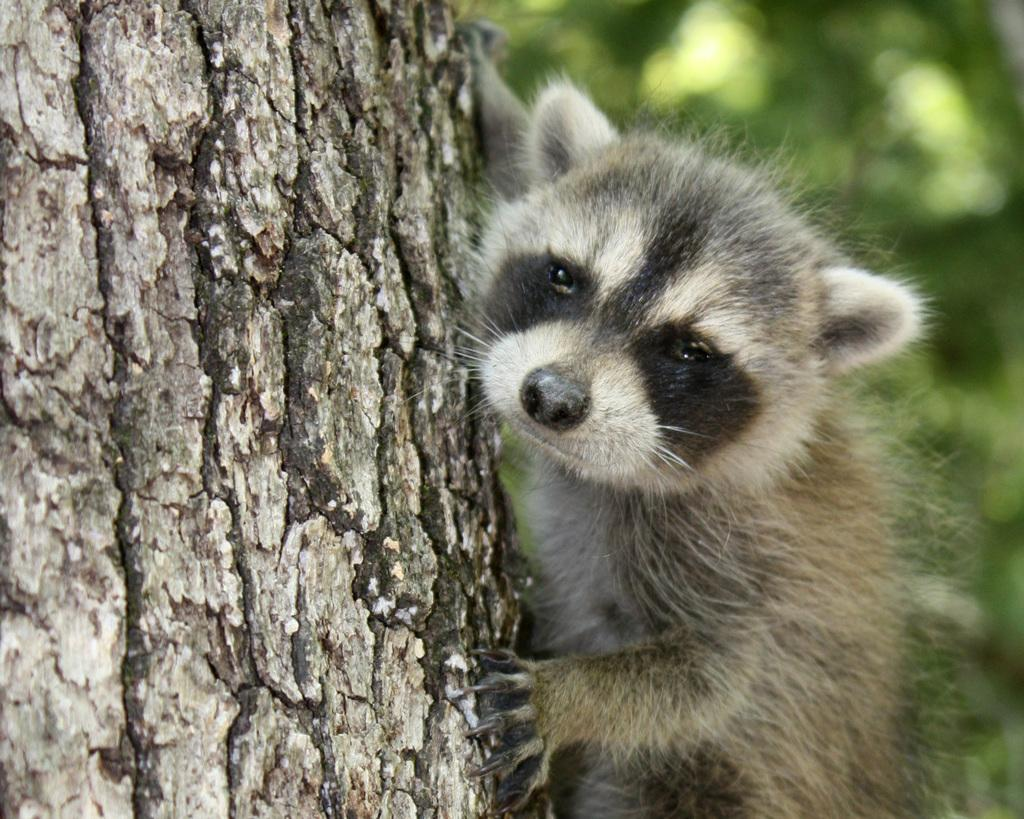What is the main subject in the image? There is an animal on a tree in the image. What type of hat is the animal wearing in the image? There is no hat present in the image; the animal is on a tree without any hat. 